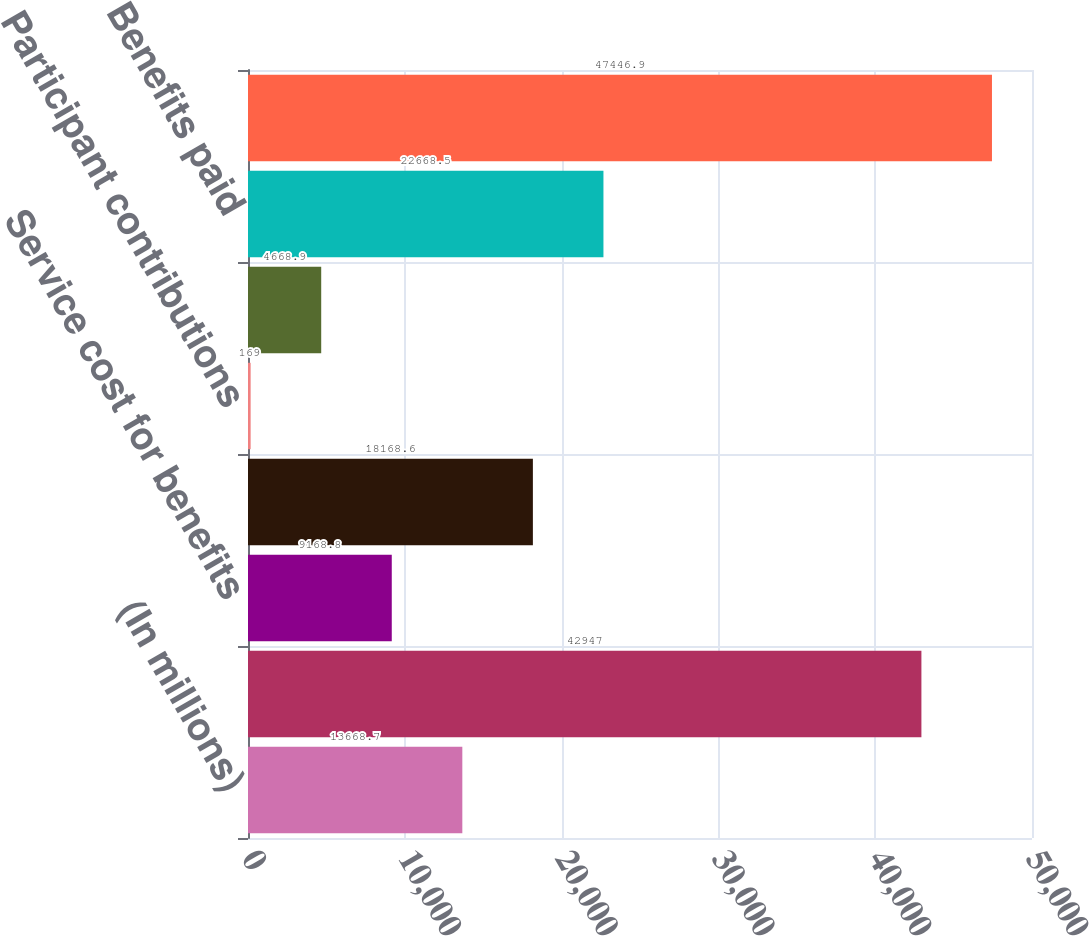<chart> <loc_0><loc_0><loc_500><loc_500><bar_chart><fcel>(In millions)<fcel>Balance at January 1<fcel>Service cost for benefits<fcel>Interest cost on benefit<fcel>Participant contributions<fcel>Actuarial loss (gain)^(a)<fcel>Benefits paid<fcel>Balance at December 31^(b)<nl><fcel>13668.7<fcel>42947<fcel>9168.8<fcel>18168.6<fcel>169<fcel>4668.9<fcel>22668.5<fcel>47446.9<nl></chart> 